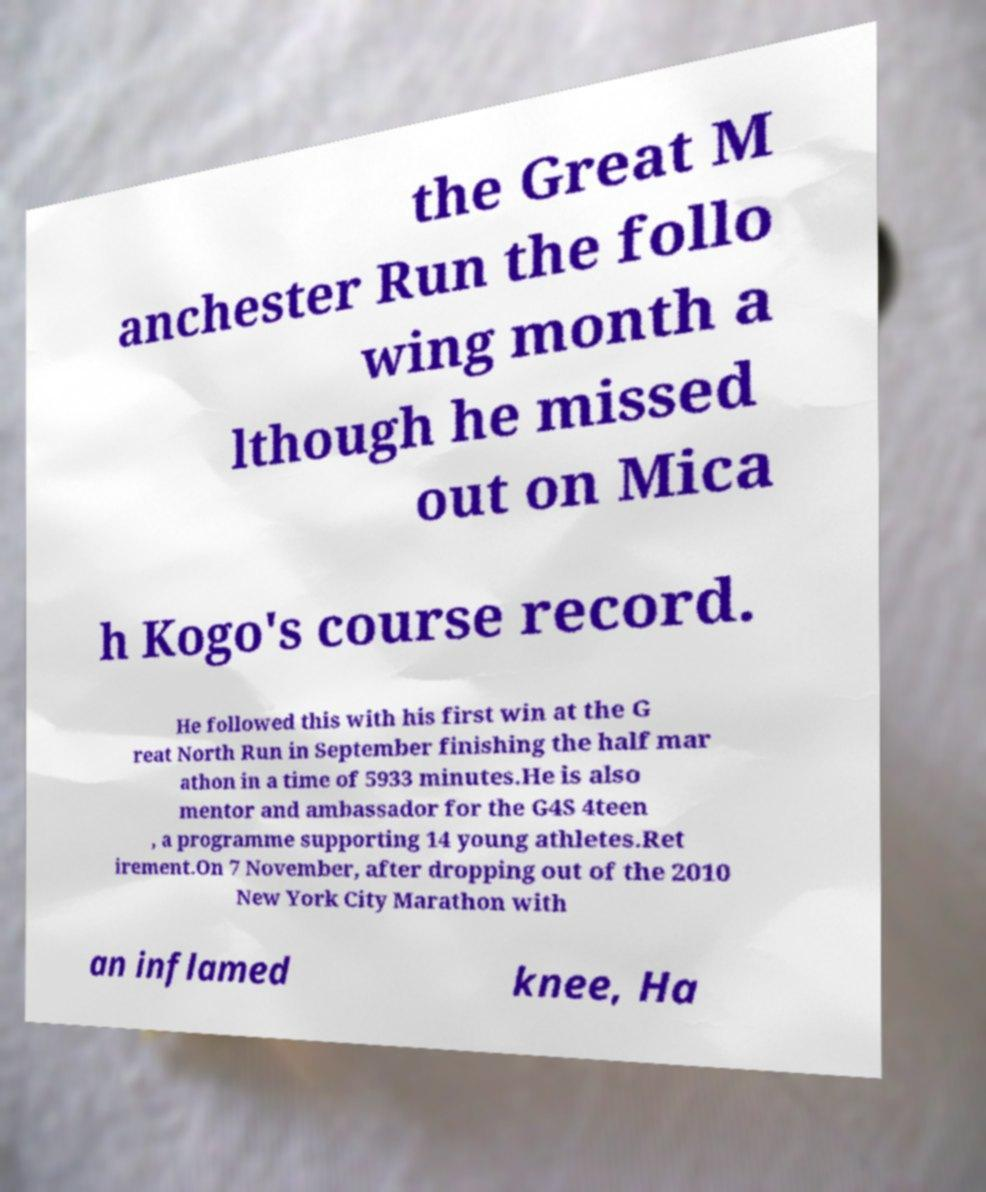Can you read and provide the text displayed in the image?This photo seems to have some interesting text. Can you extract and type it out for me? the Great M anchester Run the follo wing month a lthough he missed out on Mica h Kogo's course record. He followed this with his first win at the G reat North Run in September finishing the half mar athon in a time of 5933 minutes.He is also mentor and ambassador for the G4S 4teen , a programme supporting 14 young athletes.Ret irement.On 7 November, after dropping out of the 2010 New York City Marathon with an inflamed knee, Ha 